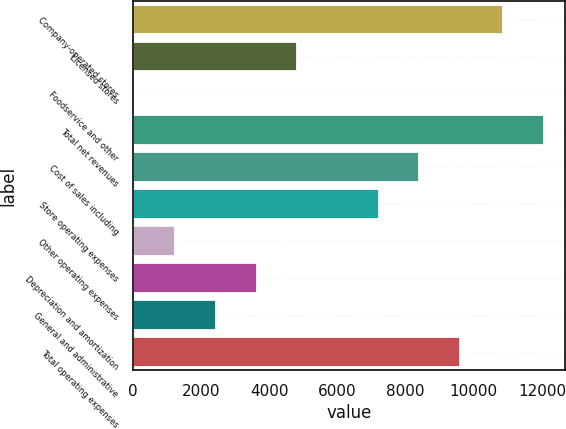Convert chart to OTSL. <chart><loc_0><loc_0><loc_500><loc_500><bar_chart><fcel>Company-operated stores<fcel>Licensed stores<fcel>Foodservice and other<fcel>Total net revenues<fcel>Cost of sales including<fcel>Store operating expenses<fcel>Other operating expenses<fcel>Depreciation and amortization<fcel>General and administrative<fcel>Total operating expenses<nl><fcel>10866.5<fcel>4815.66<fcel>39.1<fcel>12060.6<fcel>8398.08<fcel>7203.94<fcel>1233.24<fcel>3621.52<fcel>2427.38<fcel>9592.22<nl></chart> 